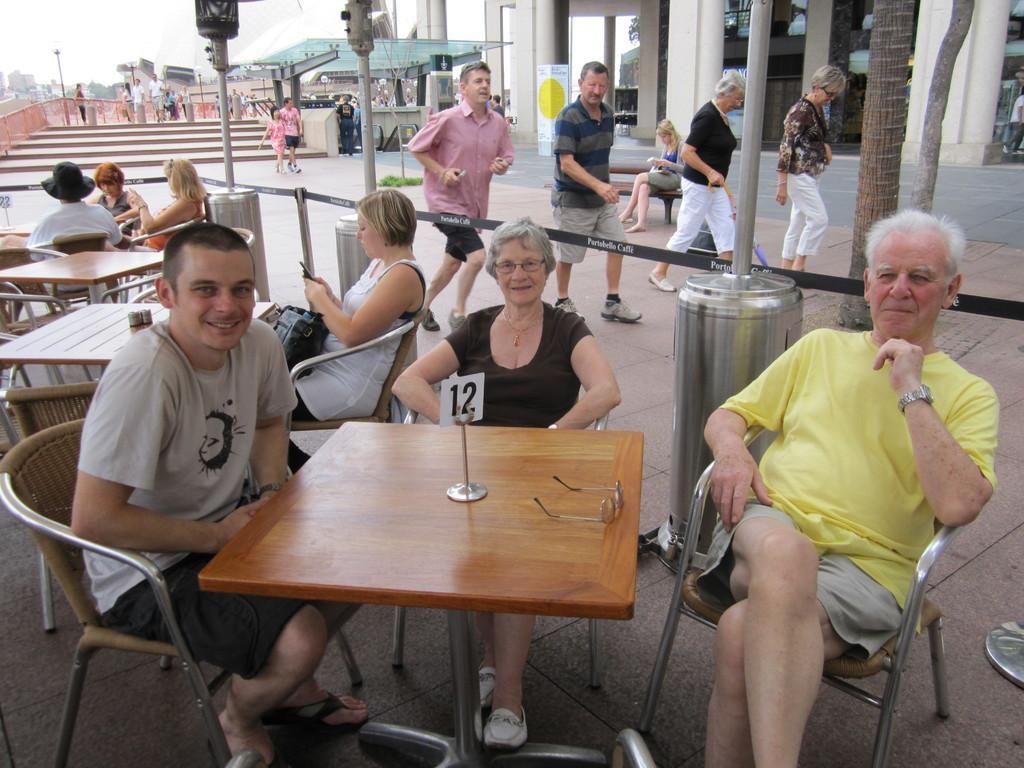How would you summarize this image in a sentence or two? This picture shows a group of people seated on the chairs and few are walking and man is running and we see stairs and a house and couple of trees and we see tables 